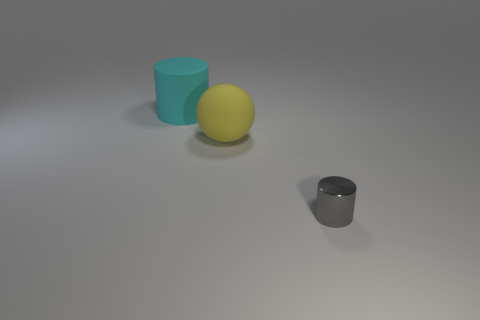Add 1 large spheres. How many objects exist? 4 Subtract all spheres. How many objects are left? 2 Add 1 yellow spheres. How many yellow spheres are left? 2 Add 3 metallic objects. How many metallic objects exist? 4 Subtract 0 green cylinders. How many objects are left? 3 Subtract all large yellow rubber spheres. Subtract all big yellow spheres. How many objects are left? 1 